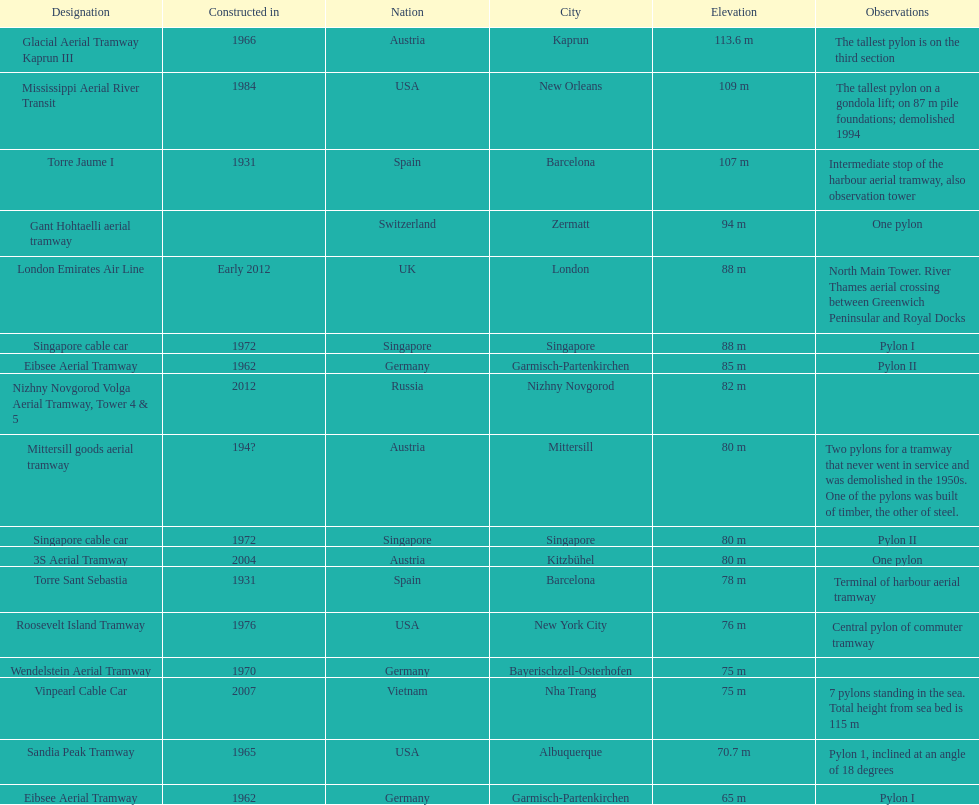List two pylons that are at most, 80 m in height. Mittersill goods aerial tramway, Singapore cable car. 